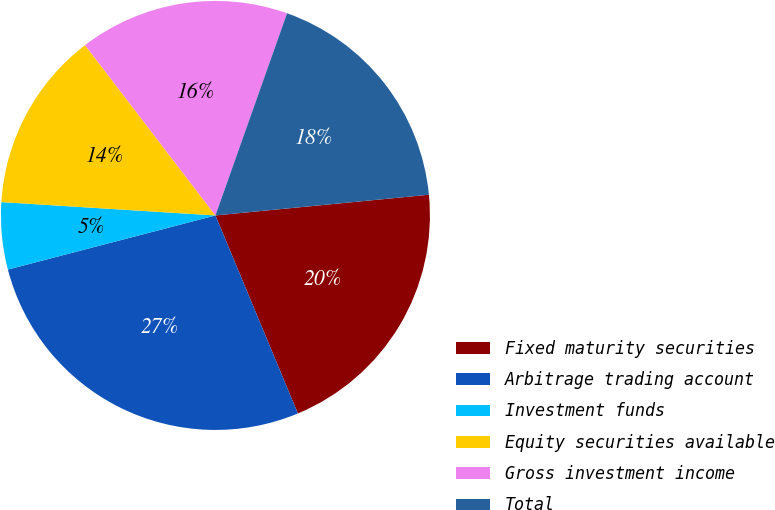Convert chart. <chart><loc_0><loc_0><loc_500><loc_500><pie_chart><fcel>Fixed maturity securities<fcel>Arbitrage trading account<fcel>Investment funds<fcel>Equity securities available<fcel>Gross investment income<fcel>Total<nl><fcel>20.26%<fcel>27.22%<fcel>5.05%<fcel>13.61%<fcel>15.82%<fcel>18.04%<nl></chart> 